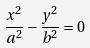<formula> <loc_0><loc_0><loc_500><loc_500>\frac { x ^ { 2 } } { a ^ { 2 } } - \frac { y ^ { 2 } } { b ^ { 2 } } = 0</formula> 